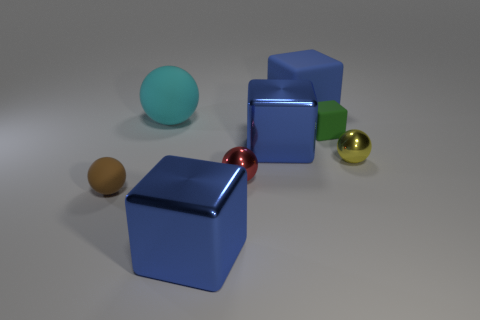Subtract all yellow shiny spheres. How many spheres are left? 3 Subtract all green cubes. How many cubes are left? 3 Subtract 0 purple blocks. How many objects are left? 8 Subtract 2 blocks. How many blocks are left? 2 Subtract all brown spheres. Subtract all brown cylinders. How many spheres are left? 3 Subtract all cyan cylinders. How many yellow blocks are left? 0 Subtract all yellow things. Subtract all blocks. How many objects are left? 3 Add 2 rubber spheres. How many rubber spheres are left? 4 Add 2 tiny brown matte spheres. How many tiny brown matte spheres exist? 3 Add 1 large rubber cylinders. How many objects exist? 9 